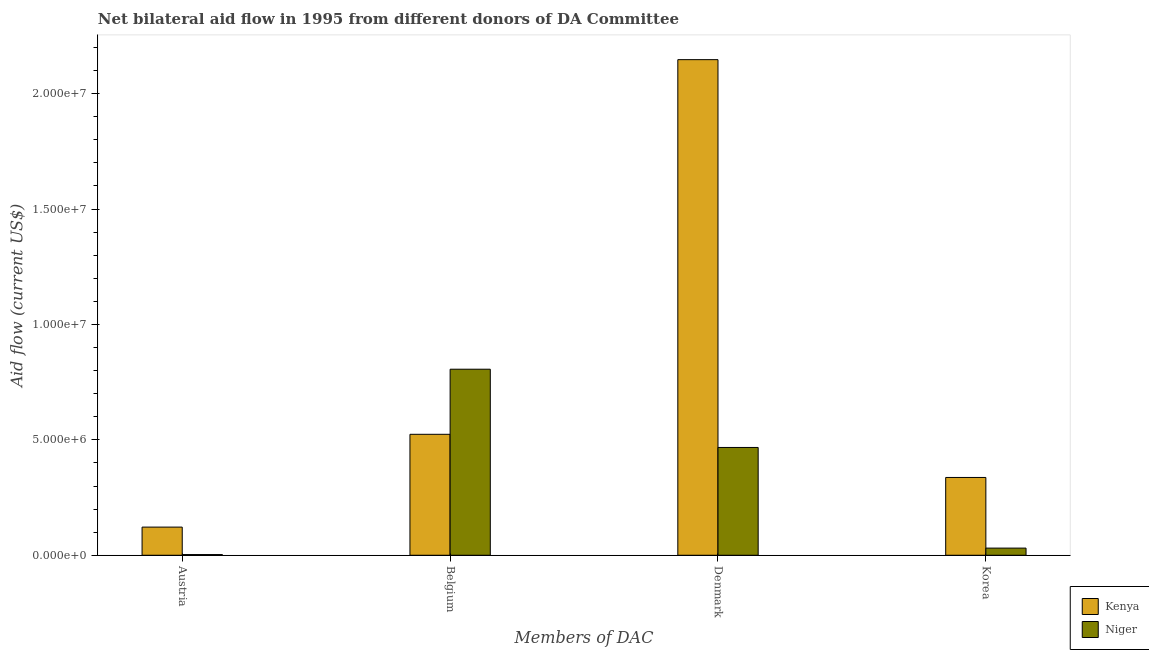How many different coloured bars are there?
Give a very brief answer. 2. Are the number of bars per tick equal to the number of legend labels?
Provide a short and direct response. Yes. How many bars are there on the 3rd tick from the right?
Your answer should be very brief. 2. What is the amount of aid given by belgium in Niger?
Provide a succinct answer. 8.06e+06. Across all countries, what is the maximum amount of aid given by denmark?
Keep it short and to the point. 2.15e+07. Across all countries, what is the minimum amount of aid given by belgium?
Make the answer very short. 5.24e+06. In which country was the amount of aid given by austria maximum?
Offer a terse response. Kenya. In which country was the amount of aid given by belgium minimum?
Offer a very short reply. Kenya. What is the total amount of aid given by denmark in the graph?
Your answer should be very brief. 2.61e+07. What is the difference between the amount of aid given by belgium in Niger and that in Kenya?
Keep it short and to the point. 2.82e+06. What is the difference between the amount of aid given by belgium in Niger and the amount of aid given by korea in Kenya?
Offer a very short reply. 4.69e+06. What is the average amount of aid given by denmark per country?
Provide a succinct answer. 1.31e+07. What is the difference between the amount of aid given by austria and amount of aid given by denmark in Kenya?
Give a very brief answer. -2.02e+07. In how many countries, is the amount of aid given by korea greater than 19000000 US$?
Offer a very short reply. 0. What is the ratio of the amount of aid given by denmark in Niger to that in Kenya?
Provide a short and direct response. 0.22. Is the amount of aid given by austria in Niger less than that in Kenya?
Your answer should be compact. Yes. Is the difference between the amount of aid given by korea in Kenya and Niger greater than the difference between the amount of aid given by denmark in Kenya and Niger?
Your answer should be very brief. No. What is the difference between the highest and the second highest amount of aid given by denmark?
Keep it short and to the point. 1.68e+07. What is the difference between the highest and the lowest amount of aid given by korea?
Make the answer very short. 3.06e+06. What does the 2nd bar from the left in Belgium represents?
Offer a terse response. Niger. What does the 2nd bar from the right in Denmark represents?
Your response must be concise. Kenya. Are all the bars in the graph horizontal?
Ensure brevity in your answer.  No. Are the values on the major ticks of Y-axis written in scientific E-notation?
Your answer should be compact. Yes. Does the graph contain grids?
Ensure brevity in your answer.  No. What is the title of the graph?
Your answer should be very brief. Net bilateral aid flow in 1995 from different donors of DA Committee. What is the label or title of the X-axis?
Offer a very short reply. Members of DAC. What is the Aid flow (current US$) of Kenya in Austria?
Ensure brevity in your answer.  1.22e+06. What is the Aid flow (current US$) of Niger in Austria?
Offer a very short reply. 3.00e+04. What is the Aid flow (current US$) of Kenya in Belgium?
Provide a short and direct response. 5.24e+06. What is the Aid flow (current US$) in Niger in Belgium?
Provide a succinct answer. 8.06e+06. What is the Aid flow (current US$) of Kenya in Denmark?
Provide a succinct answer. 2.15e+07. What is the Aid flow (current US$) of Niger in Denmark?
Provide a short and direct response. 4.67e+06. What is the Aid flow (current US$) in Kenya in Korea?
Offer a terse response. 3.37e+06. Across all Members of DAC, what is the maximum Aid flow (current US$) in Kenya?
Your response must be concise. 2.15e+07. Across all Members of DAC, what is the maximum Aid flow (current US$) in Niger?
Ensure brevity in your answer.  8.06e+06. Across all Members of DAC, what is the minimum Aid flow (current US$) in Kenya?
Ensure brevity in your answer.  1.22e+06. Across all Members of DAC, what is the minimum Aid flow (current US$) in Niger?
Give a very brief answer. 3.00e+04. What is the total Aid flow (current US$) in Kenya in the graph?
Offer a terse response. 3.13e+07. What is the total Aid flow (current US$) of Niger in the graph?
Your response must be concise. 1.31e+07. What is the difference between the Aid flow (current US$) in Kenya in Austria and that in Belgium?
Give a very brief answer. -4.02e+06. What is the difference between the Aid flow (current US$) of Niger in Austria and that in Belgium?
Offer a very short reply. -8.03e+06. What is the difference between the Aid flow (current US$) of Kenya in Austria and that in Denmark?
Your answer should be very brief. -2.02e+07. What is the difference between the Aid flow (current US$) of Niger in Austria and that in Denmark?
Ensure brevity in your answer.  -4.64e+06. What is the difference between the Aid flow (current US$) in Kenya in Austria and that in Korea?
Offer a very short reply. -2.15e+06. What is the difference between the Aid flow (current US$) of Niger in Austria and that in Korea?
Your answer should be very brief. -2.80e+05. What is the difference between the Aid flow (current US$) of Kenya in Belgium and that in Denmark?
Give a very brief answer. -1.62e+07. What is the difference between the Aid flow (current US$) in Niger in Belgium and that in Denmark?
Make the answer very short. 3.39e+06. What is the difference between the Aid flow (current US$) of Kenya in Belgium and that in Korea?
Offer a terse response. 1.87e+06. What is the difference between the Aid flow (current US$) of Niger in Belgium and that in Korea?
Your response must be concise. 7.75e+06. What is the difference between the Aid flow (current US$) in Kenya in Denmark and that in Korea?
Offer a terse response. 1.81e+07. What is the difference between the Aid flow (current US$) in Niger in Denmark and that in Korea?
Provide a succinct answer. 4.36e+06. What is the difference between the Aid flow (current US$) in Kenya in Austria and the Aid flow (current US$) in Niger in Belgium?
Ensure brevity in your answer.  -6.84e+06. What is the difference between the Aid flow (current US$) in Kenya in Austria and the Aid flow (current US$) in Niger in Denmark?
Your answer should be compact. -3.45e+06. What is the difference between the Aid flow (current US$) of Kenya in Austria and the Aid flow (current US$) of Niger in Korea?
Your response must be concise. 9.10e+05. What is the difference between the Aid flow (current US$) in Kenya in Belgium and the Aid flow (current US$) in Niger in Denmark?
Your response must be concise. 5.70e+05. What is the difference between the Aid flow (current US$) in Kenya in Belgium and the Aid flow (current US$) in Niger in Korea?
Your answer should be compact. 4.93e+06. What is the difference between the Aid flow (current US$) of Kenya in Denmark and the Aid flow (current US$) of Niger in Korea?
Your response must be concise. 2.12e+07. What is the average Aid flow (current US$) of Kenya per Members of DAC?
Keep it short and to the point. 7.82e+06. What is the average Aid flow (current US$) in Niger per Members of DAC?
Keep it short and to the point. 3.27e+06. What is the difference between the Aid flow (current US$) of Kenya and Aid flow (current US$) of Niger in Austria?
Make the answer very short. 1.19e+06. What is the difference between the Aid flow (current US$) of Kenya and Aid flow (current US$) of Niger in Belgium?
Make the answer very short. -2.82e+06. What is the difference between the Aid flow (current US$) in Kenya and Aid flow (current US$) in Niger in Denmark?
Your answer should be very brief. 1.68e+07. What is the difference between the Aid flow (current US$) of Kenya and Aid flow (current US$) of Niger in Korea?
Give a very brief answer. 3.06e+06. What is the ratio of the Aid flow (current US$) in Kenya in Austria to that in Belgium?
Your answer should be very brief. 0.23. What is the ratio of the Aid flow (current US$) of Niger in Austria to that in Belgium?
Keep it short and to the point. 0. What is the ratio of the Aid flow (current US$) of Kenya in Austria to that in Denmark?
Your answer should be very brief. 0.06. What is the ratio of the Aid flow (current US$) of Niger in Austria to that in Denmark?
Your answer should be compact. 0.01. What is the ratio of the Aid flow (current US$) of Kenya in Austria to that in Korea?
Offer a very short reply. 0.36. What is the ratio of the Aid flow (current US$) in Niger in Austria to that in Korea?
Give a very brief answer. 0.1. What is the ratio of the Aid flow (current US$) of Kenya in Belgium to that in Denmark?
Your answer should be very brief. 0.24. What is the ratio of the Aid flow (current US$) in Niger in Belgium to that in Denmark?
Your response must be concise. 1.73. What is the ratio of the Aid flow (current US$) of Kenya in Belgium to that in Korea?
Offer a very short reply. 1.55. What is the ratio of the Aid flow (current US$) of Kenya in Denmark to that in Korea?
Your answer should be very brief. 6.37. What is the ratio of the Aid flow (current US$) of Niger in Denmark to that in Korea?
Offer a terse response. 15.06. What is the difference between the highest and the second highest Aid flow (current US$) of Kenya?
Keep it short and to the point. 1.62e+07. What is the difference between the highest and the second highest Aid flow (current US$) of Niger?
Offer a very short reply. 3.39e+06. What is the difference between the highest and the lowest Aid flow (current US$) of Kenya?
Keep it short and to the point. 2.02e+07. What is the difference between the highest and the lowest Aid flow (current US$) of Niger?
Your answer should be compact. 8.03e+06. 